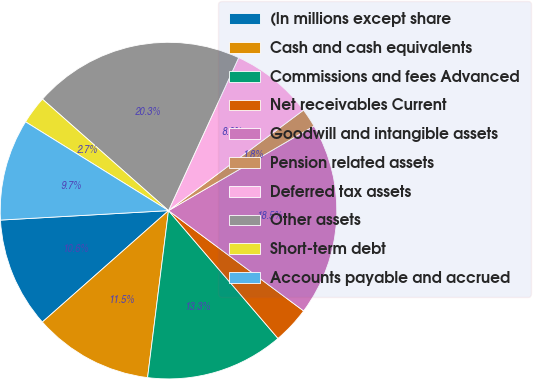Convert chart to OTSL. <chart><loc_0><loc_0><loc_500><loc_500><pie_chart><fcel>(In millions except share<fcel>Cash and cash equivalents<fcel>Commissions and fees Advanced<fcel>Net receivables Current<fcel>Goodwill and intangible assets<fcel>Pension related assets<fcel>Deferred tax assets<fcel>Other assets<fcel>Short-term debt<fcel>Accounts payable and accrued<nl><fcel>10.62%<fcel>11.5%<fcel>13.26%<fcel>3.56%<fcel>18.55%<fcel>1.8%<fcel>7.97%<fcel>20.32%<fcel>2.68%<fcel>9.74%<nl></chart> 